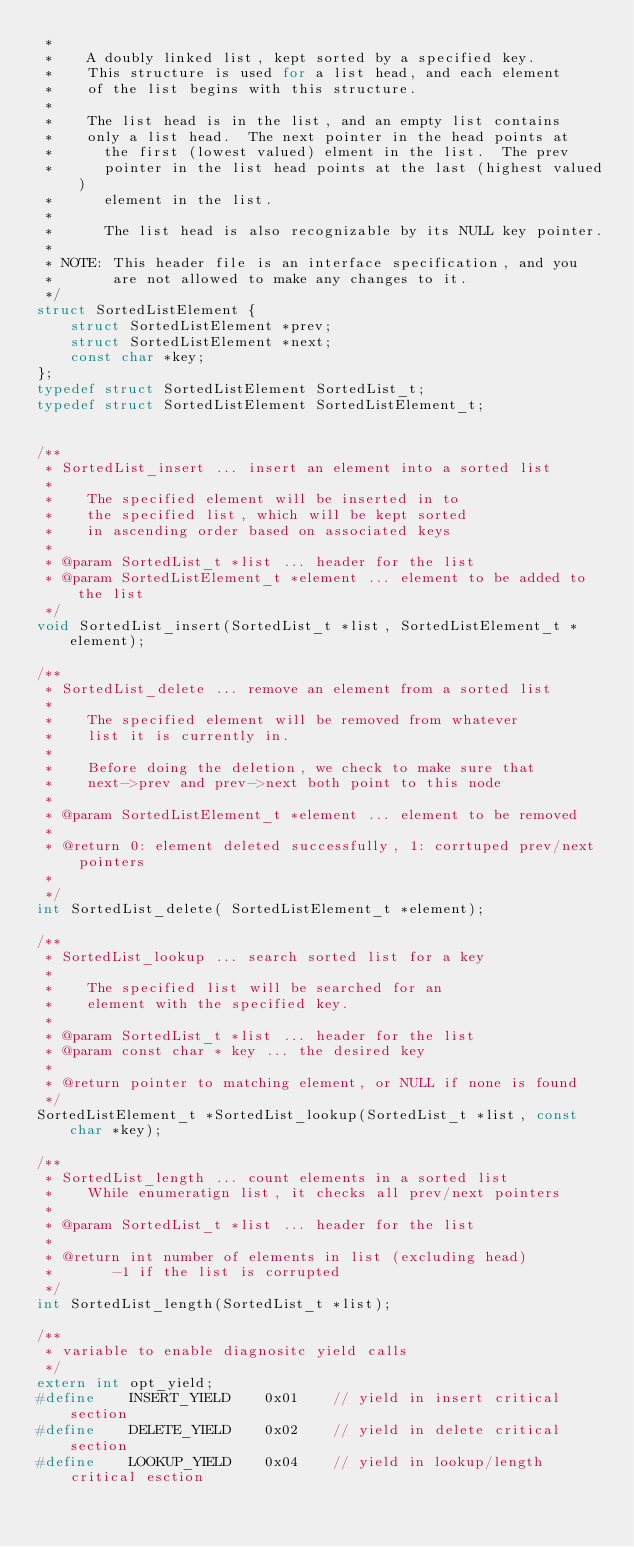Convert code to text. <code><loc_0><loc_0><loc_500><loc_500><_C_> *
 *    A doubly linked list, kept sorted by a specified key.
 *    This structure is used for a list head, and each element
 *    of the list begins with this structure.
 *
 *    The list head is in the list, and an empty list contains
 *    only a list head.  The next pointer in the head points at
 *      the first (lowest valued) elment in the list.  The prev
 *      pointer in the list head points at the last (highest valued)
 *      element in the list.
 *
 *      The list head is also recognizable by its NULL key pointer.
 *
 * NOTE: This header file is an interface specification, and you
 *       are not allowed to make any changes to it.
 */
struct SortedListElement {
    struct SortedListElement *prev;
    struct SortedListElement *next;
    const char *key;
};
typedef struct SortedListElement SortedList_t;
typedef struct SortedListElement SortedListElement_t;


/**
 * SortedList_insert ... insert an element into a sorted list
 *
 *    The specified element will be inserted in to
 *    the specified list, which will be kept sorted
 *    in ascending order based on associated keys
 *
 * @param SortedList_t *list ... header for the list
 * @param SortedListElement_t *element ... element to be added to the list
 */
void SortedList_insert(SortedList_t *list, SortedListElement_t *element);

/**
 * SortedList_delete ... remove an element from a sorted list
 *
 *    The specified element will be removed from whatever
 *    list it is currently in.
 *
 *    Before doing the deletion, we check to make sure that
 *    next->prev and prev->next both point to this node
 *
 * @param SortedListElement_t *element ... element to be removed
 *
 * @return 0: element deleted successfully, 1: corrtuped prev/next pointers
 *
 */
int SortedList_delete( SortedListElement_t *element);

/**
 * SortedList_lookup ... search sorted list for a key
 *
 *    The specified list will be searched for an
 *    element with the specified key.
 *
 * @param SortedList_t *list ... header for the list
 * @param const char * key ... the desired key
 *
 * @return pointer to matching element, or NULL if none is found
 */
SortedListElement_t *SortedList_lookup(SortedList_t *list, const char *key);

/**
 * SortedList_length ... count elements in a sorted list
 *    While enumeratign list, it checks all prev/next pointers
 *
 * @param SortedList_t *list ... header for the list
 *
 * @return int number of elements in list (excluding head)
 *       -1 if the list is corrupted
 */
int SortedList_length(SortedList_t *list);

/**
 * variable to enable diagnositc yield calls
 */
extern int opt_yield;
#define    INSERT_YIELD    0x01    // yield in insert critical section
#define    DELETE_YIELD    0x02    // yield in delete critical section
#define    LOOKUP_YIELD    0x04    // yield in lookup/length critical esction
</code> 